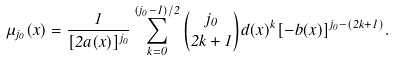<formula> <loc_0><loc_0><loc_500><loc_500>\mu _ { j _ { 0 } } ( x ) = \frac { 1 } { [ 2 a ( x ) ] ^ { j _ { 0 } } } \sum _ { k = 0 } ^ { ( j _ { 0 } - 1 ) / 2 } \binom { j _ { 0 } } { 2 k + 1 } d ( x ) ^ { k } [ - b ( x ) ] ^ { j _ { 0 } - ( 2 k + 1 ) } .</formula> 